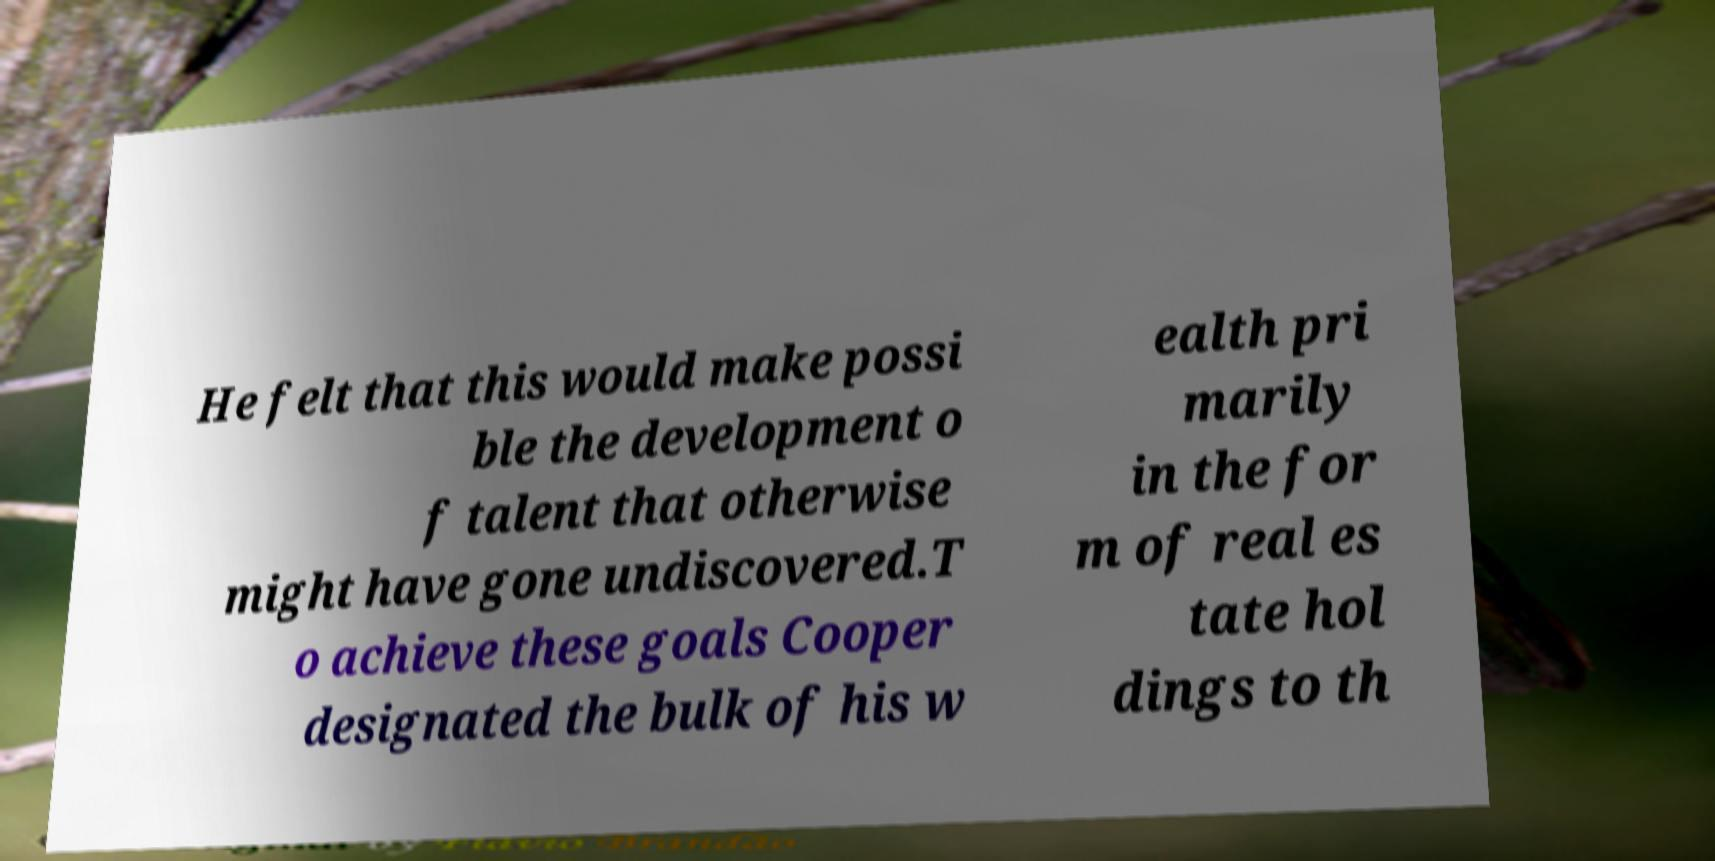Can you accurately transcribe the text from the provided image for me? He felt that this would make possi ble the development o f talent that otherwise might have gone undiscovered.T o achieve these goals Cooper designated the bulk of his w ealth pri marily in the for m of real es tate hol dings to th 